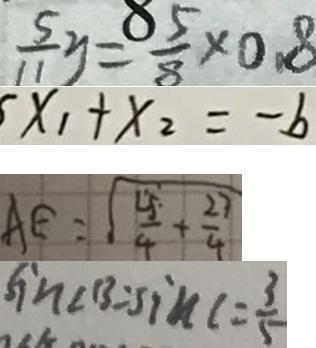<formula> <loc_0><loc_0><loc_500><loc_500>\frac { 5 } { 1 1 } y = \frac { 8 5 } { 8 } \times 0 . 8 
 x _ { 1 } + x _ { 2 } = - b 
 A E = \sqrt { \frac { 2 5 } { 4 } + \frac { 2 7 } { 4 } } 
 \sin \angle B = \sin \angle C = \frac { 3 } { 5 }</formula> 